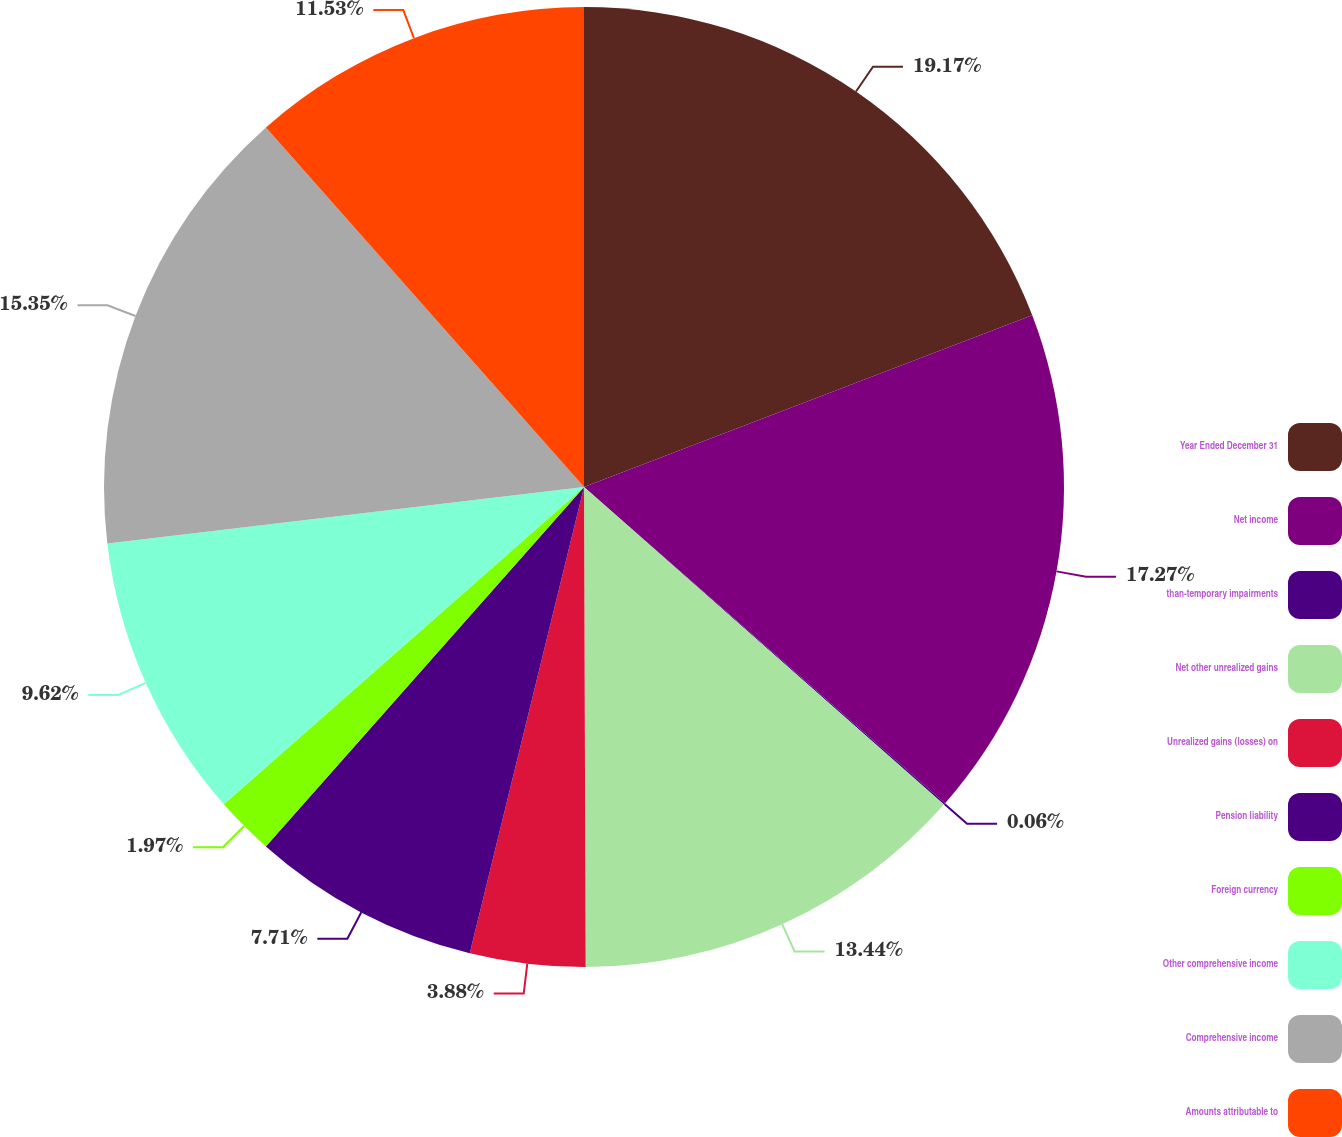Convert chart to OTSL. <chart><loc_0><loc_0><loc_500><loc_500><pie_chart><fcel>Year Ended December 31<fcel>Net income<fcel>than-temporary impairments<fcel>Net other unrealized gains<fcel>Unrealized gains (losses) on<fcel>Pension liability<fcel>Foreign currency<fcel>Other comprehensive income<fcel>Comprehensive income<fcel>Amounts attributable to<nl><fcel>19.18%<fcel>17.27%<fcel>0.06%<fcel>13.44%<fcel>3.88%<fcel>7.71%<fcel>1.97%<fcel>9.62%<fcel>15.35%<fcel>11.53%<nl></chart> 